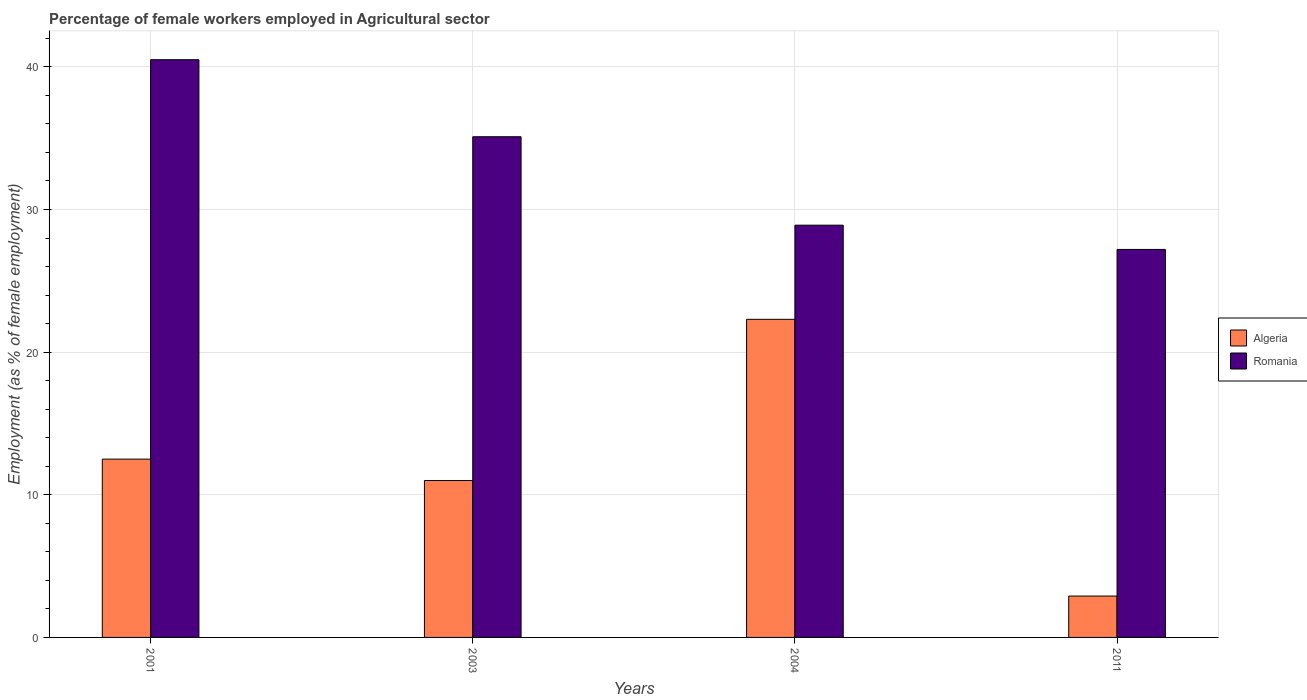How many different coloured bars are there?
Give a very brief answer. 2. How many groups of bars are there?
Make the answer very short. 4. What is the label of the 4th group of bars from the left?
Give a very brief answer. 2011. In how many cases, is the number of bars for a given year not equal to the number of legend labels?
Provide a short and direct response. 0. What is the percentage of females employed in Agricultural sector in Algeria in 2001?
Ensure brevity in your answer.  12.5. Across all years, what is the maximum percentage of females employed in Agricultural sector in Algeria?
Provide a succinct answer. 22.3. Across all years, what is the minimum percentage of females employed in Agricultural sector in Algeria?
Offer a terse response. 2.9. What is the total percentage of females employed in Agricultural sector in Romania in the graph?
Offer a terse response. 131.7. What is the difference between the percentage of females employed in Agricultural sector in Algeria in 2004 and that in 2011?
Provide a succinct answer. 19.4. What is the difference between the percentage of females employed in Agricultural sector in Romania in 2001 and the percentage of females employed in Agricultural sector in Algeria in 2004?
Give a very brief answer. 18.2. What is the average percentage of females employed in Agricultural sector in Algeria per year?
Your response must be concise. 12.17. In the year 2003, what is the difference between the percentage of females employed in Agricultural sector in Algeria and percentage of females employed in Agricultural sector in Romania?
Offer a very short reply. -24.1. What is the ratio of the percentage of females employed in Agricultural sector in Romania in 2003 to that in 2011?
Give a very brief answer. 1.29. Is the difference between the percentage of females employed in Agricultural sector in Algeria in 2001 and 2011 greater than the difference between the percentage of females employed in Agricultural sector in Romania in 2001 and 2011?
Ensure brevity in your answer.  No. What is the difference between the highest and the second highest percentage of females employed in Agricultural sector in Algeria?
Offer a very short reply. 9.8. What is the difference between the highest and the lowest percentage of females employed in Agricultural sector in Romania?
Give a very brief answer. 13.3. Is the sum of the percentage of females employed in Agricultural sector in Algeria in 2001 and 2003 greater than the maximum percentage of females employed in Agricultural sector in Romania across all years?
Provide a short and direct response. No. What does the 2nd bar from the left in 2001 represents?
Provide a succinct answer. Romania. What does the 2nd bar from the right in 2003 represents?
Your answer should be compact. Algeria. How many bars are there?
Keep it short and to the point. 8. What is the difference between two consecutive major ticks on the Y-axis?
Your answer should be very brief. 10. Are the values on the major ticks of Y-axis written in scientific E-notation?
Give a very brief answer. No. Where does the legend appear in the graph?
Your answer should be very brief. Center right. How are the legend labels stacked?
Your answer should be compact. Vertical. What is the title of the graph?
Your answer should be compact. Percentage of female workers employed in Agricultural sector. Does "Switzerland" appear as one of the legend labels in the graph?
Your answer should be compact. No. What is the label or title of the X-axis?
Ensure brevity in your answer.  Years. What is the label or title of the Y-axis?
Ensure brevity in your answer.  Employment (as % of female employment). What is the Employment (as % of female employment) of Algeria in 2001?
Give a very brief answer. 12.5. What is the Employment (as % of female employment) in Romania in 2001?
Make the answer very short. 40.5. What is the Employment (as % of female employment) of Algeria in 2003?
Provide a succinct answer. 11. What is the Employment (as % of female employment) in Romania in 2003?
Provide a succinct answer. 35.1. What is the Employment (as % of female employment) of Algeria in 2004?
Make the answer very short. 22.3. What is the Employment (as % of female employment) in Romania in 2004?
Your response must be concise. 28.9. What is the Employment (as % of female employment) of Algeria in 2011?
Give a very brief answer. 2.9. What is the Employment (as % of female employment) in Romania in 2011?
Your answer should be very brief. 27.2. Across all years, what is the maximum Employment (as % of female employment) in Algeria?
Offer a very short reply. 22.3. Across all years, what is the maximum Employment (as % of female employment) in Romania?
Your answer should be compact. 40.5. Across all years, what is the minimum Employment (as % of female employment) in Algeria?
Your answer should be compact. 2.9. Across all years, what is the minimum Employment (as % of female employment) in Romania?
Your answer should be very brief. 27.2. What is the total Employment (as % of female employment) of Algeria in the graph?
Provide a short and direct response. 48.7. What is the total Employment (as % of female employment) of Romania in the graph?
Your answer should be compact. 131.7. What is the difference between the Employment (as % of female employment) of Algeria in 2001 and that in 2004?
Provide a short and direct response. -9.8. What is the difference between the Employment (as % of female employment) of Romania in 2001 and that in 2004?
Ensure brevity in your answer.  11.6. What is the difference between the Employment (as % of female employment) of Romania in 2001 and that in 2011?
Provide a short and direct response. 13.3. What is the difference between the Employment (as % of female employment) in Algeria in 2003 and that in 2004?
Offer a very short reply. -11.3. What is the difference between the Employment (as % of female employment) of Romania in 2003 and that in 2004?
Ensure brevity in your answer.  6.2. What is the difference between the Employment (as % of female employment) in Romania in 2003 and that in 2011?
Keep it short and to the point. 7.9. What is the difference between the Employment (as % of female employment) of Romania in 2004 and that in 2011?
Your answer should be very brief. 1.7. What is the difference between the Employment (as % of female employment) of Algeria in 2001 and the Employment (as % of female employment) of Romania in 2003?
Your answer should be very brief. -22.6. What is the difference between the Employment (as % of female employment) of Algeria in 2001 and the Employment (as % of female employment) of Romania in 2004?
Offer a very short reply. -16.4. What is the difference between the Employment (as % of female employment) in Algeria in 2001 and the Employment (as % of female employment) in Romania in 2011?
Give a very brief answer. -14.7. What is the difference between the Employment (as % of female employment) in Algeria in 2003 and the Employment (as % of female employment) in Romania in 2004?
Provide a short and direct response. -17.9. What is the difference between the Employment (as % of female employment) in Algeria in 2003 and the Employment (as % of female employment) in Romania in 2011?
Your answer should be very brief. -16.2. What is the difference between the Employment (as % of female employment) in Algeria in 2004 and the Employment (as % of female employment) in Romania in 2011?
Your answer should be very brief. -4.9. What is the average Employment (as % of female employment) of Algeria per year?
Your answer should be very brief. 12.18. What is the average Employment (as % of female employment) of Romania per year?
Make the answer very short. 32.92. In the year 2001, what is the difference between the Employment (as % of female employment) of Algeria and Employment (as % of female employment) of Romania?
Your answer should be compact. -28. In the year 2003, what is the difference between the Employment (as % of female employment) of Algeria and Employment (as % of female employment) of Romania?
Your response must be concise. -24.1. In the year 2004, what is the difference between the Employment (as % of female employment) in Algeria and Employment (as % of female employment) in Romania?
Give a very brief answer. -6.6. In the year 2011, what is the difference between the Employment (as % of female employment) in Algeria and Employment (as % of female employment) in Romania?
Provide a succinct answer. -24.3. What is the ratio of the Employment (as % of female employment) in Algeria in 2001 to that in 2003?
Your answer should be very brief. 1.14. What is the ratio of the Employment (as % of female employment) of Romania in 2001 to that in 2003?
Your response must be concise. 1.15. What is the ratio of the Employment (as % of female employment) of Algeria in 2001 to that in 2004?
Ensure brevity in your answer.  0.56. What is the ratio of the Employment (as % of female employment) in Romania in 2001 to that in 2004?
Your answer should be compact. 1.4. What is the ratio of the Employment (as % of female employment) in Algeria in 2001 to that in 2011?
Offer a terse response. 4.31. What is the ratio of the Employment (as % of female employment) of Romania in 2001 to that in 2011?
Provide a short and direct response. 1.49. What is the ratio of the Employment (as % of female employment) of Algeria in 2003 to that in 2004?
Your answer should be compact. 0.49. What is the ratio of the Employment (as % of female employment) in Romania in 2003 to that in 2004?
Offer a very short reply. 1.21. What is the ratio of the Employment (as % of female employment) in Algeria in 2003 to that in 2011?
Keep it short and to the point. 3.79. What is the ratio of the Employment (as % of female employment) in Romania in 2003 to that in 2011?
Your answer should be compact. 1.29. What is the ratio of the Employment (as % of female employment) in Algeria in 2004 to that in 2011?
Provide a succinct answer. 7.69. What is the ratio of the Employment (as % of female employment) in Romania in 2004 to that in 2011?
Offer a terse response. 1.06. What is the difference between the highest and the second highest Employment (as % of female employment) in Algeria?
Your answer should be compact. 9.8. What is the difference between the highest and the second highest Employment (as % of female employment) of Romania?
Offer a terse response. 5.4. What is the difference between the highest and the lowest Employment (as % of female employment) in Algeria?
Offer a very short reply. 19.4. What is the difference between the highest and the lowest Employment (as % of female employment) of Romania?
Make the answer very short. 13.3. 